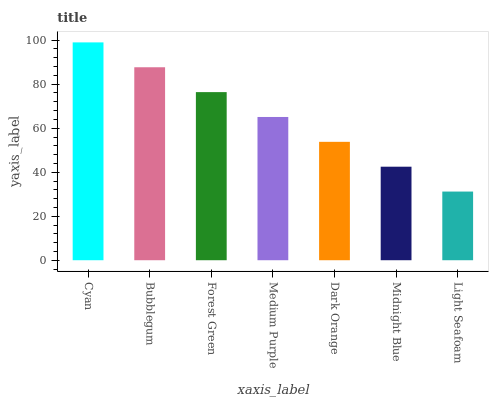Is Light Seafoam the minimum?
Answer yes or no. Yes. Is Cyan the maximum?
Answer yes or no. Yes. Is Bubblegum the minimum?
Answer yes or no. No. Is Bubblegum the maximum?
Answer yes or no. No. Is Cyan greater than Bubblegum?
Answer yes or no. Yes. Is Bubblegum less than Cyan?
Answer yes or no. Yes. Is Bubblegum greater than Cyan?
Answer yes or no. No. Is Cyan less than Bubblegum?
Answer yes or no. No. Is Medium Purple the high median?
Answer yes or no. Yes. Is Medium Purple the low median?
Answer yes or no. Yes. Is Forest Green the high median?
Answer yes or no. No. Is Dark Orange the low median?
Answer yes or no. No. 